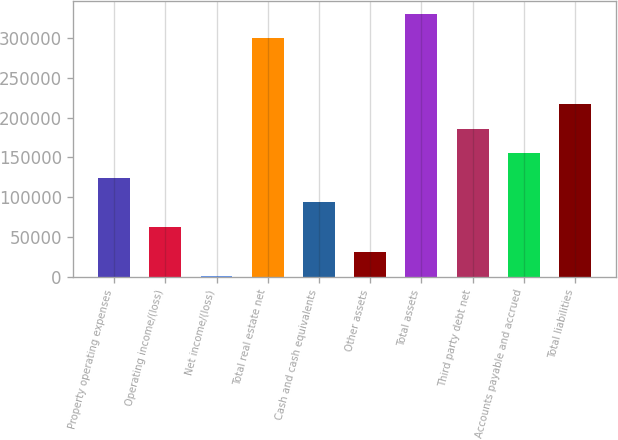Convert chart to OTSL. <chart><loc_0><loc_0><loc_500><loc_500><bar_chart><fcel>Property operating expenses<fcel>Operating income/(loss)<fcel>Net income/(loss)<fcel>Total real estate net<fcel>Cash and cash equivalents<fcel>Other assets<fcel>Total assets<fcel>Third party debt net<fcel>Accounts payable and accrued<fcel>Total liabilities<nl><fcel>124209<fcel>62611.2<fcel>1013<fcel>299420<fcel>93410.3<fcel>31812.1<fcel>330219<fcel>185808<fcel>155008<fcel>216607<nl></chart> 